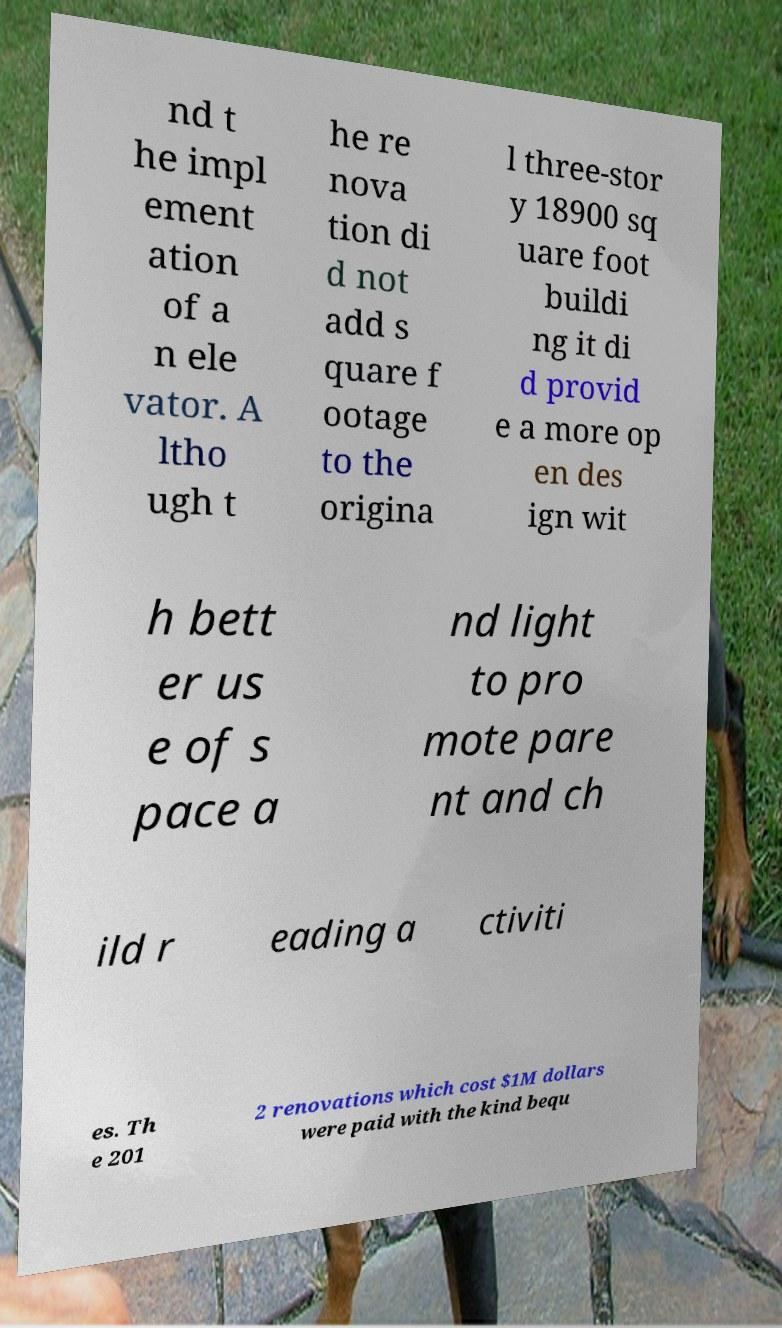Please read and relay the text visible in this image. What does it say? nd t he impl ement ation of a n ele vator. A ltho ugh t he re nova tion di d not add s quare f ootage to the origina l three-stor y 18900 sq uare foot buildi ng it di d provid e a more op en des ign wit h bett er us e of s pace a nd light to pro mote pare nt and ch ild r eading a ctiviti es. Th e 201 2 renovations which cost $1M dollars were paid with the kind bequ 